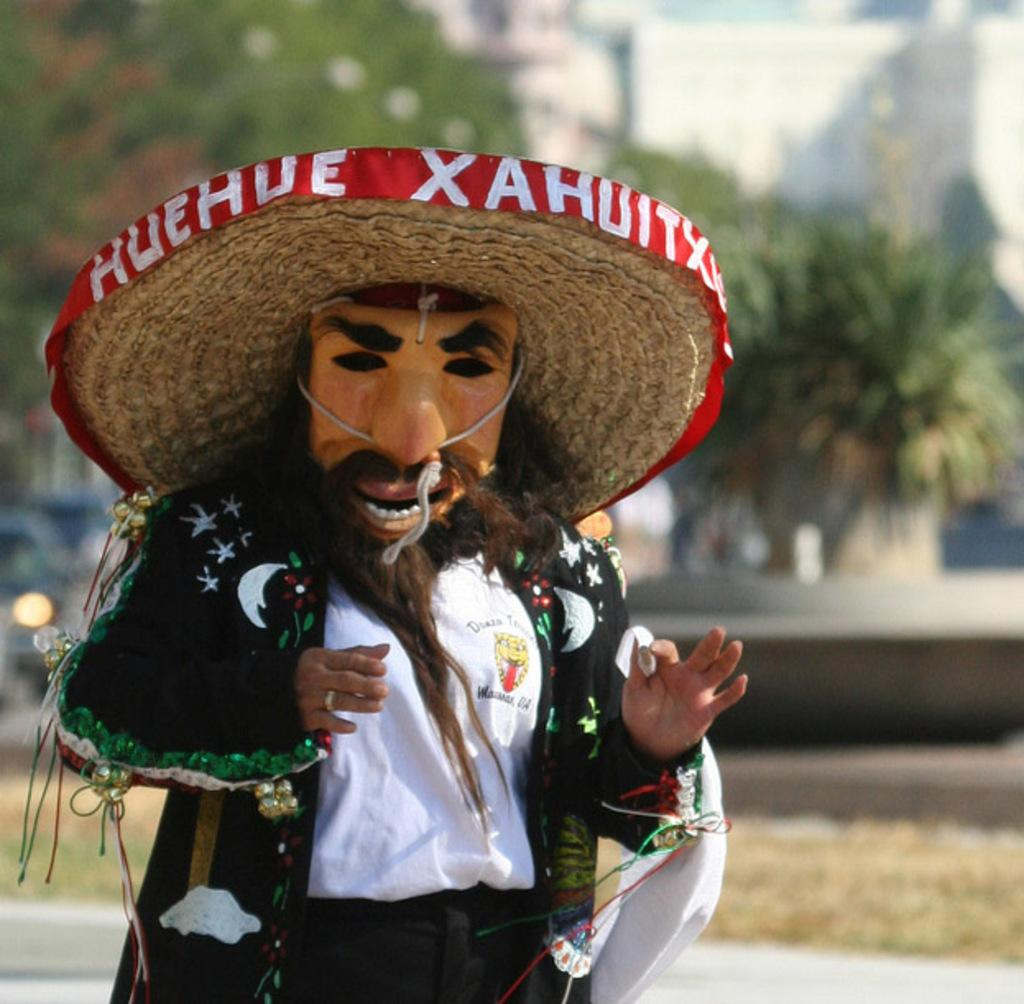Who or what is the main subject in the image? There is a person in the image. What is the person wearing on their face? The person is wearing a mask on their face. Where is the person located in the image? The person is on the left side of the image. What can be seen in the background of the image? There are trees in the background of the image. What type of chair is the person sitting on during their discovery of breakfast? There is no chair, discovery, or breakfast present in the image; it only features a person wearing a mask on their face and standing on the left side of the image. 